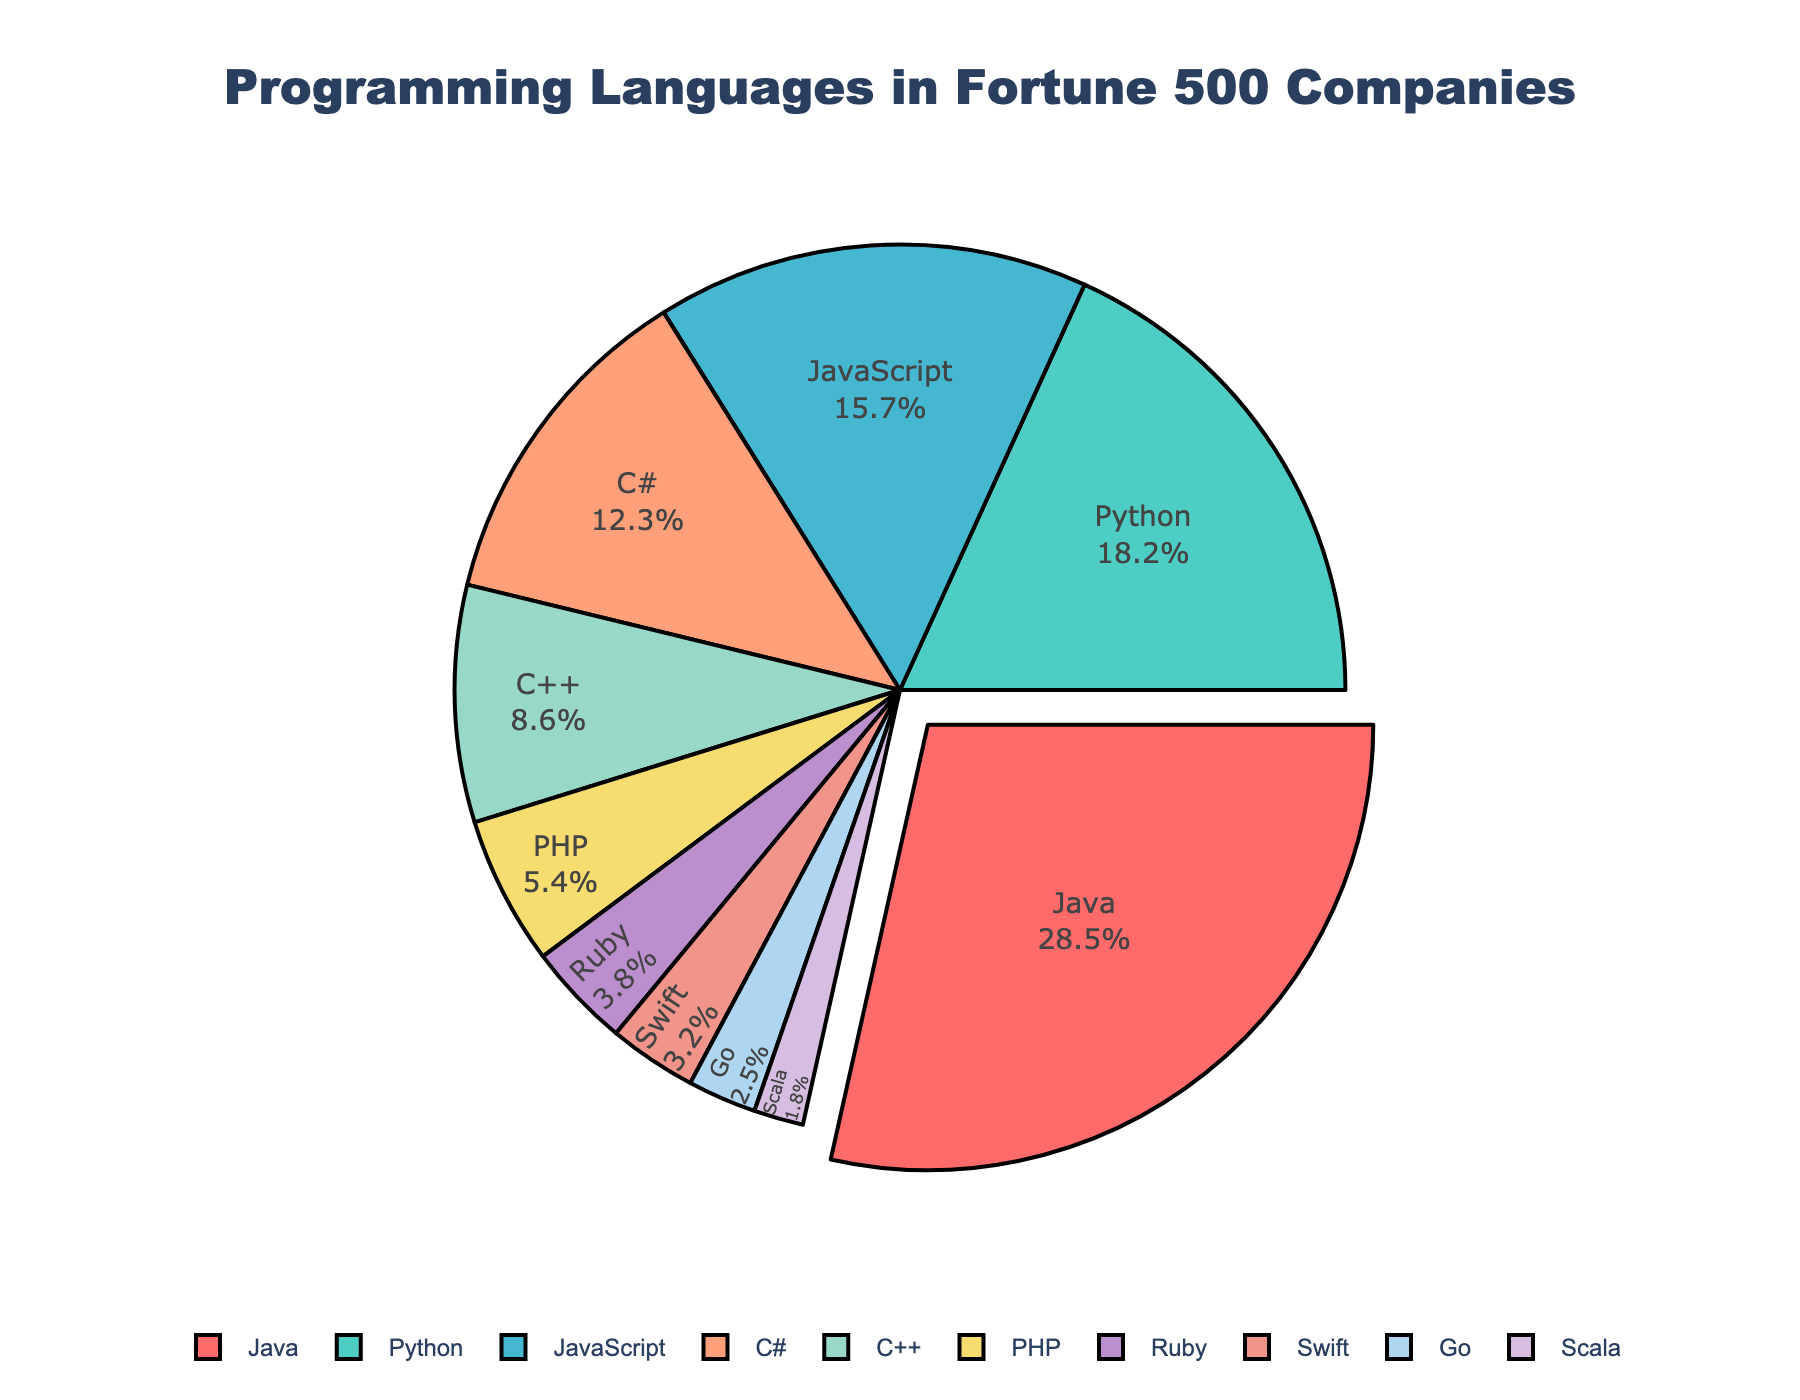which language occupies the largest proportion of the pie chart? The largest proportion is represented by the language with the largest percentage value. According to the data, Java has the highest percentage at 28.5%, making it the largest portion of the chart.
Answer: Java what is the percentage difference between Java and Python usage? To find the difference, subtract the percentage value for Python from the percentage value for Java. Java is 28.5% and Python is 18.2%. So, 28.5% - 18.2% = 10.3%.
Answer: 10.3% which programming languages together make up more than half of the total usage? First, sum the percentages starting from the highest until the total exceeds 50%. Java (28.5%) + Python (18.2%) + JavaScript (15.7%) = 62.4%. Thus, Java, Python, and JavaScript together make up more than half of the total usage.
Answer: Java, Python, JavaScript how much more popular is C# compared to Go? Subtract the percentage value of Go from that of C#. C# is 12.3% and Go is 2.5%. So, 12.3% - 2.5% = 9.8%.
Answer: 9.8% what are the programming languages that occupy the smallest portion of the pie chart? The smallest portion is represented by the language with the smallest percentage value. According to the data, Scala has the smallest percentage at 1.8%.
Answer: Scala between Ruby and Swift, which one is more prevalent and by how much? Compare their percentages. Ruby has 3.8% and Swift has 3.2%. The difference is 3.8% - 3.2% = 0.6%. Ruby is more prevalent.
Answer: Ruby by 0.6% how many programming languages have a usage percentage of over 10%? Count the languages that have a percentage value greater than 10%. Java (28.5%), Python (18.2%), JavaScript (15.7%), and C# (12.3%) each have over 10%. That makes 4 languages.
Answer: 4 which programming language is represented by the green color in the pie chart? The color green is associated with the second largest section after Java, which is Python, depicted with the percentage value of 18.2%.
Answer: Python what is the total percentage of languages labeled with some form of the letter 'C' (e.g., C#, C++)? Add the percentages of C# (12.3%) and C++ (8.6%). So, 12.3% + 8.6% = 20.9%.
Answer: 20.9% which two languages combined have a percentage similar to Java's? Find two languages whose combined percentage is closest to 28.5%. Python (18.2%) + C++ (8.6%) = 26.8%, and JavaScript (15.7%) + C# (12.3%) = 28%. The latter, JavaScript and C#, when combined, are closest to Java's 28.5%.
Answer: JavaScript and C# 